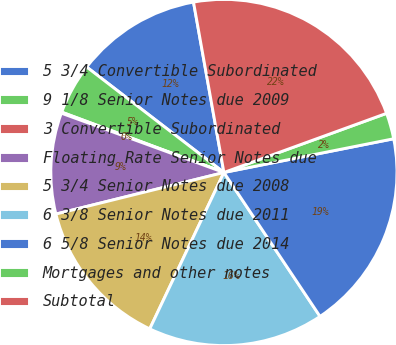<chart> <loc_0><loc_0><loc_500><loc_500><pie_chart><fcel>5 3/4 Convertible Subordinated<fcel>9 1/8 Senior Notes due 2009<fcel>3 Convertible Subordinated<fcel>Floating Rate Senior Notes due<fcel>5 3/4 Senior Notes due 2008<fcel>6 3/8 Senior Notes due 2011<fcel>6 5/8 Senior Notes due 2014<fcel>Mortgages and other notes<fcel>Subtotal<nl><fcel>11.76%<fcel>4.76%<fcel>0.1%<fcel>9.43%<fcel>14.09%<fcel>16.42%<fcel>18.75%<fcel>2.43%<fcel>22.26%<nl></chart> 